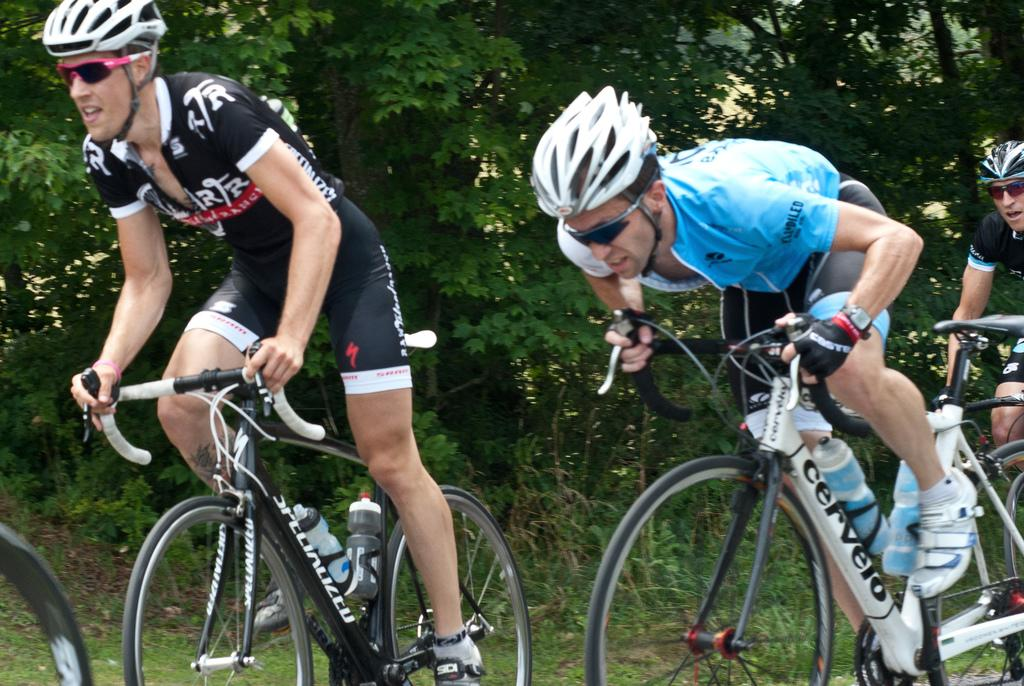How many people are in the image? There are three persons in the image. What protective gear are the persons wearing? The persons are wearing helmets and goggles. What activity are the persons engaged in? The persons are riding cycles. What can be seen attached to the cycles? There are bottles on the cycles. What is visible in the background of the image? There are trees in the background of the image. What type of star can be seen in the image? There is no star visible in the image; it features three persons riding cycles with trees in the background. Are the persons in the image sleeping? No, the persons in the image are not sleeping; they are riding cycles. 